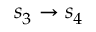<formula> <loc_0><loc_0><loc_500><loc_500>s _ { 3 } \rightarrow s _ { 4 }</formula> 